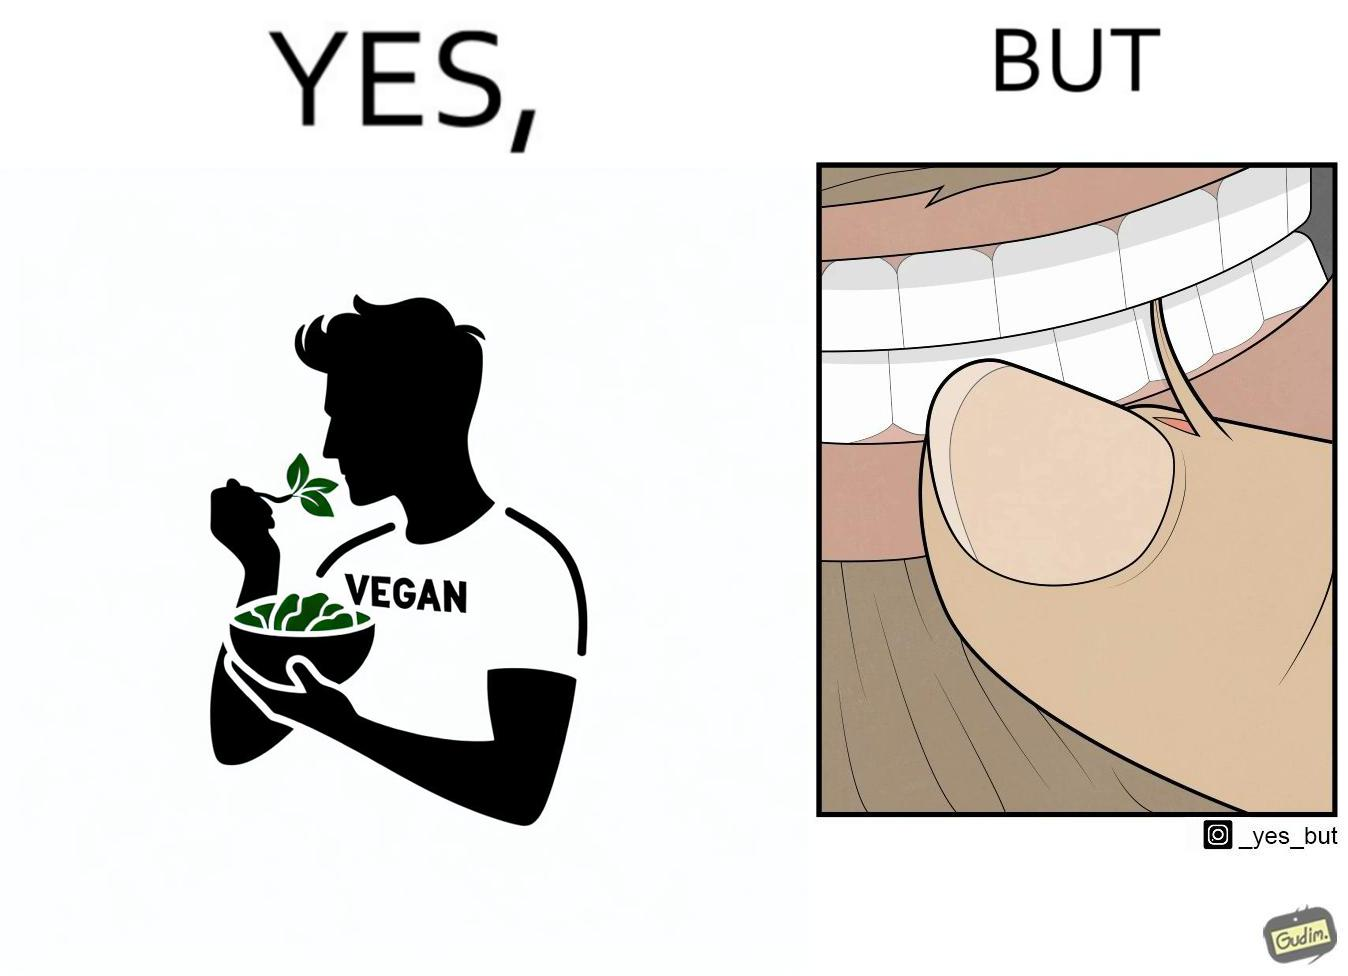What makes this image funny or satirical? The image is funny because while the man claims to be vegan, he is biting skin off his own hand. 